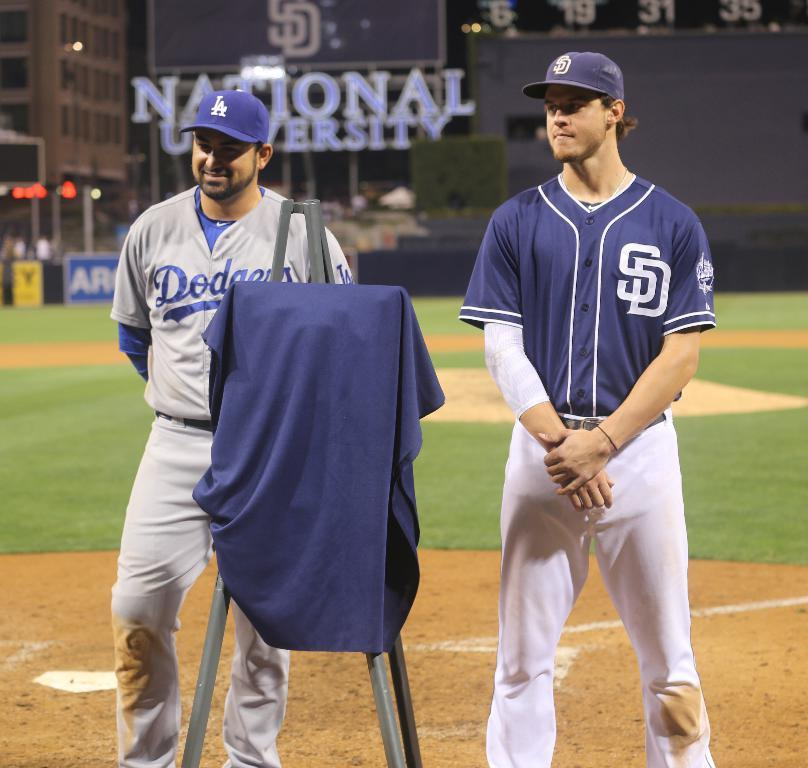<image>
Share a concise interpretation of the image provided. a dodger and padre stand behind an easel 